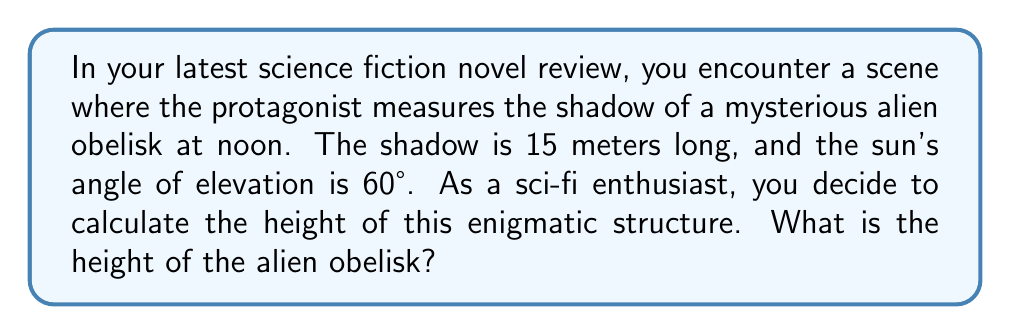Help me with this question. To solve this problem, we can use trigonometry, specifically the tangent function. Here's a step-by-step explanation:

1. Let's define our variables:
   $h$ = height of the obelisk (unknown)
   $s$ = length of the shadow = 15 meters
   $\theta$ = angle of elevation of the sun = 60°

2. We can visualize this as a right triangle:

[asy]
import geometry;

size(200);
pair A = (0,0), B = (15,0), C = (0,26);
draw(A--B--C--A);
draw(rightanglemark(A,B,C,8));

label("15 m", (B/2), S);
label("$h$", (C/2), W);
label("60°", A, SE);

dot("A", A, SW);
dot("B", B, SE);
dot("C", C, N);
[/asy]

3. The tangent of an angle in a right triangle is the ratio of the opposite side to the adjacent side. In this case:

   $\tan 60° = \frac{\text{opposite}}{\text{adjacent}} = \frac{h}{s}$

4. We can express this as an equation:

   $\tan 60° = \frac{h}{15}$

5. To solve for $h$, we multiply both sides by 15:

   $15 \tan 60° = h$

6. We know that $\tan 60° = \sqrt{3}$, so we can substitute this:

   $15 \sqrt{3} = h$

7. Simplify:
   $h = 15 \sqrt{3} \approx 25.98$ meters

Therefore, the height of the alien obelisk is approximately 25.98 meters.
Answer: $$h = 15\sqrt{3} \approx 25.98 \text{ meters}$$ 